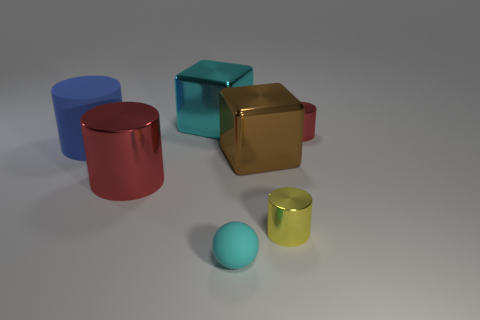Add 2 large cyan rubber objects. How many objects exist? 9 Subtract all big cyan matte cylinders. Subtract all big brown blocks. How many objects are left? 6 Add 7 brown blocks. How many brown blocks are left? 8 Add 5 tiny balls. How many tiny balls exist? 6 Subtract 0 purple blocks. How many objects are left? 7 Subtract all blocks. How many objects are left? 5 